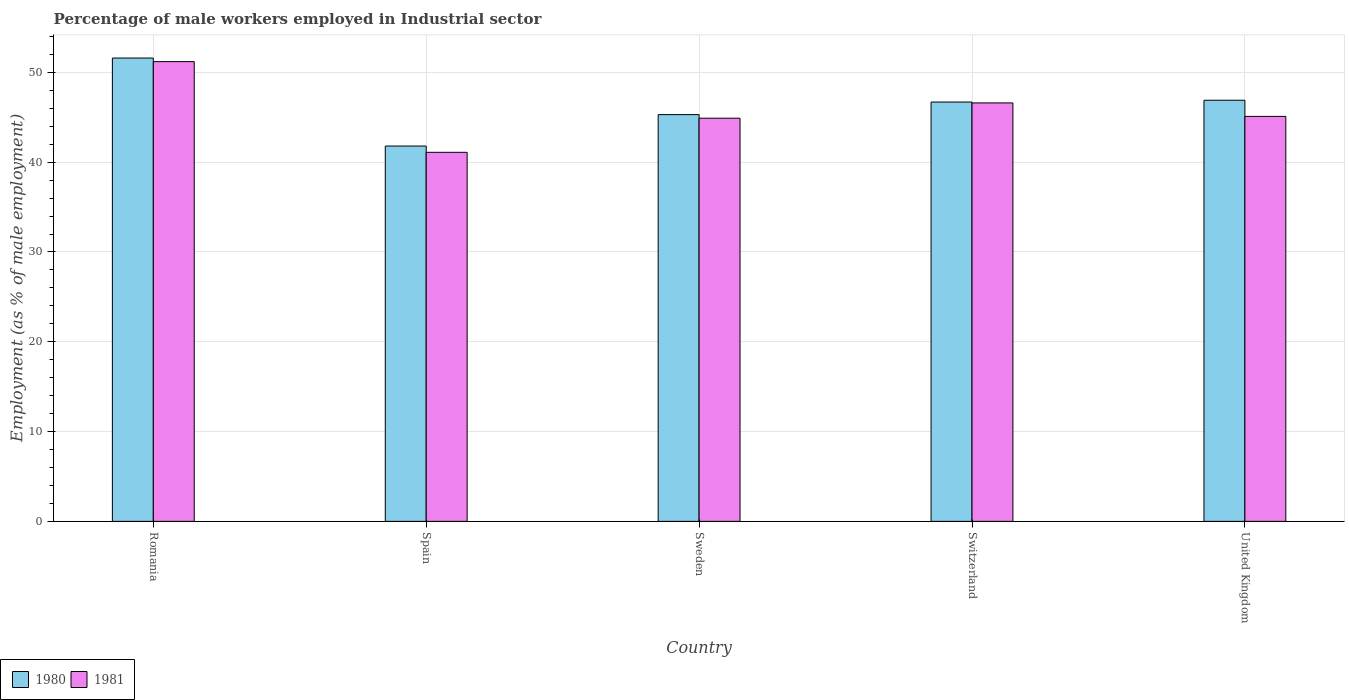Are the number of bars on each tick of the X-axis equal?
Offer a terse response. Yes. How many bars are there on the 5th tick from the right?
Your answer should be compact. 2. What is the label of the 4th group of bars from the left?
Your answer should be compact. Switzerland. What is the percentage of male workers employed in Industrial sector in 1981 in Romania?
Provide a succinct answer. 51.2. Across all countries, what is the maximum percentage of male workers employed in Industrial sector in 1980?
Your answer should be very brief. 51.6. Across all countries, what is the minimum percentage of male workers employed in Industrial sector in 1981?
Give a very brief answer. 41.1. In which country was the percentage of male workers employed in Industrial sector in 1981 maximum?
Offer a terse response. Romania. In which country was the percentage of male workers employed in Industrial sector in 1980 minimum?
Ensure brevity in your answer.  Spain. What is the total percentage of male workers employed in Industrial sector in 1980 in the graph?
Your answer should be compact. 232.3. What is the difference between the percentage of male workers employed in Industrial sector in 1981 in Romania and that in United Kingdom?
Offer a very short reply. 6.1. What is the difference between the percentage of male workers employed in Industrial sector in 1980 in Switzerland and the percentage of male workers employed in Industrial sector in 1981 in Spain?
Your answer should be very brief. 5.6. What is the average percentage of male workers employed in Industrial sector in 1981 per country?
Offer a terse response. 45.78. What is the difference between the percentage of male workers employed in Industrial sector of/in 1980 and percentage of male workers employed in Industrial sector of/in 1981 in Spain?
Offer a very short reply. 0.7. What is the ratio of the percentage of male workers employed in Industrial sector in 1980 in Sweden to that in United Kingdom?
Make the answer very short. 0.97. What is the difference between the highest and the second highest percentage of male workers employed in Industrial sector in 1980?
Ensure brevity in your answer.  -4.9. What is the difference between the highest and the lowest percentage of male workers employed in Industrial sector in 1981?
Your answer should be very brief. 10.1. In how many countries, is the percentage of male workers employed in Industrial sector in 1980 greater than the average percentage of male workers employed in Industrial sector in 1980 taken over all countries?
Give a very brief answer. 3. Is the sum of the percentage of male workers employed in Industrial sector in 1980 in Sweden and Switzerland greater than the maximum percentage of male workers employed in Industrial sector in 1981 across all countries?
Offer a very short reply. Yes. What does the 1st bar from the left in Sweden represents?
Provide a short and direct response. 1980. Are the values on the major ticks of Y-axis written in scientific E-notation?
Your response must be concise. No. Does the graph contain grids?
Give a very brief answer. Yes. How many legend labels are there?
Provide a short and direct response. 2. What is the title of the graph?
Your answer should be very brief. Percentage of male workers employed in Industrial sector. What is the label or title of the X-axis?
Offer a terse response. Country. What is the label or title of the Y-axis?
Provide a short and direct response. Employment (as % of male employment). What is the Employment (as % of male employment) in 1980 in Romania?
Ensure brevity in your answer.  51.6. What is the Employment (as % of male employment) in 1981 in Romania?
Your response must be concise. 51.2. What is the Employment (as % of male employment) in 1980 in Spain?
Ensure brevity in your answer.  41.8. What is the Employment (as % of male employment) of 1981 in Spain?
Give a very brief answer. 41.1. What is the Employment (as % of male employment) of 1980 in Sweden?
Make the answer very short. 45.3. What is the Employment (as % of male employment) in 1981 in Sweden?
Give a very brief answer. 44.9. What is the Employment (as % of male employment) of 1980 in Switzerland?
Your answer should be compact. 46.7. What is the Employment (as % of male employment) in 1981 in Switzerland?
Your answer should be compact. 46.6. What is the Employment (as % of male employment) of 1980 in United Kingdom?
Keep it short and to the point. 46.9. What is the Employment (as % of male employment) in 1981 in United Kingdom?
Your answer should be very brief. 45.1. Across all countries, what is the maximum Employment (as % of male employment) of 1980?
Make the answer very short. 51.6. Across all countries, what is the maximum Employment (as % of male employment) of 1981?
Your response must be concise. 51.2. Across all countries, what is the minimum Employment (as % of male employment) in 1980?
Your response must be concise. 41.8. Across all countries, what is the minimum Employment (as % of male employment) in 1981?
Make the answer very short. 41.1. What is the total Employment (as % of male employment) of 1980 in the graph?
Ensure brevity in your answer.  232.3. What is the total Employment (as % of male employment) of 1981 in the graph?
Give a very brief answer. 228.9. What is the difference between the Employment (as % of male employment) of 1981 in Romania and that in Spain?
Provide a short and direct response. 10.1. What is the difference between the Employment (as % of male employment) in 1980 in Romania and that in Sweden?
Provide a short and direct response. 6.3. What is the difference between the Employment (as % of male employment) of 1980 in Romania and that in United Kingdom?
Provide a short and direct response. 4.7. What is the difference between the Employment (as % of male employment) of 1981 in Romania and that in United Kingdom?
Offer a very short reply. 6.1. What is the difference between the Employment (as % of male employment) of 1980 in Spain and that in United Kingdom?
Provide a short and direct response. -5.1. What is the difference between the Employment (as % of male employment) in 1981 in Spain and that in United Kingdom?
Ensure brevity in your answer.  -4. What is the difference between the Employment (as % of male employment) in 1981 in Sweden and that in Switzerland?
Keep it short and to the point. -1.7. What is the difference between the Employment (as % of male employment) of 1980 in Sweden and that in United Kingdom?
Keep it short and to the point. -1.6. What is the difference between the Employment (as % of male employment) in 1981 in Switzerland and that in United Kingdom?
Provide a succinct answer. 1.5. What is the difference between the Employment (as % of male employment) of 1980 in Romania and the Employment (as % of male employment) of 1981 in Spain?
Your response must be concise. 10.5. What is the difference between the Employment (as % of male employment) in 1980 in Romania and the Employment (as % of male employment) in 1981 in Sweden?
Your answer should be compact. 6.7. What is the difference between the Employment (as % of male employment) in 1980 in Romania and the Employment (as % of male employment) in 1981 in Switzerland?
Your response must be concise. 5. What is the difference between the Employment (as % of male employment) of 1980 in Spain and the Employment (as % of male employment) of 1981 in Sweden?
Your response must be concise. -3.1. What is the difference between the Employment (as % of male employment) in 1980 in Spain and the Employment (as % of male employment) in 1981 in United Kingdom?
Provide a succinct answer. -3.3. What is the difference between the Employment (as % of male employment) in 1980 in Sweden and the Employment (as % of male employment) in 1981 in Switzerland?
Offer a very short reply. -1.3. What is the difference between the Employment (as % of male employment) in 1980 in Sweden and the Employment (as % of male employment) in 1981 in United Kingdom?
Offer a terse response. 0.2. What is the difference between the Employment (as % of male employment) of 1980 in Switzerland and the Employment (as % of male employment) of 1981 in United Kingdom?
Offer a terse response. 1.6. What is the average Employment (as % of male employment) in 1980 per country?
Your response must be concise. 46.46. What is the average Employment (as % of male employment) in 1981 per country?
Your response must be concise. 45.78. What is the ratio of the Employment (as % of male employment) of 1980 in Romania to that in Spain?
Make the answer very short. 1.23. What is the ratio of the Employment (as % of male employment) in 1981 in Romania to that in Spain?
Give a very brief answer. 1.25. What is the ratio of the Employment (as % of male employment) in 1980 in Romania to that in Sweden?
Make the answer very short. 1.14. What is the ratio of the Employment (as % of male employment) in 1981 in Romania to that in Sweden?
Make the answer very short. 1.14. What is the ratio of the Employment (as % of male employment) of 1980 in Romania to that in Switzerland?
Ensure brevity in your answer.  1.1. What is the ratio of the Employment (as % of male employment) of 1981 in Romania to that in Switzerland?
Your response must be concise. 1.1. What is the ratio of the Employment (as % of male employment) in 1980 in Romania to that in United Kingdom?
Your response must be concise. 1.1. What is the ratio of the Employment (as % of male employment) in 1981 in Romania to that in United Kingdom?
Make the answer very short. 1.14. What is the ratio of the Employment (as % of male employment) of 1980 in Spain to that in Sweden?
Your response must be concise. 0.92. What is the ratio of the Employment (as % of male employment) of 1981 in Spain to that in Sweden?
Provide a short and direct response. 0.92. What is the ratio of the Employment (as % of male employment) of 1980 in Spain to that in Switzerland?
Your answer should be compact. 0.9. What is the ratio of the Employment (as % of male employment) of 1981 in Spain to that in Switzerland?
Provide a succinct answer. 0.88. What is the ratio of the Employment (as % of male employment) of 1980 in Spain to that in United Kingdom?
Your answer should be very brief. 0.89. What is the ratio of the Employment (as % of male employment) in 1981 in Spain to that in United Kingdom?
Keep it short and to the point. 0.91. What is the ratio of the Employment (as % of male employment) of 1980 in Sweden to that in Switzerland?
Offer a very short reply. 0.97. What is the ratio of the Employment (as % of male employment) in 1981 in Sweden to that in Switzerland?
Provide a short and direct response. 0.96. What is the ratio of the Employment (as % of male employment) in 1980 in Sweden to that in United Kingdom?
Give a very brief answer. 0.97. What is the ratio of the Employment (as % of male employment) in 1981 in Switzerland to that in United Kingdom?
Provide a succinct answer. 1.03. 